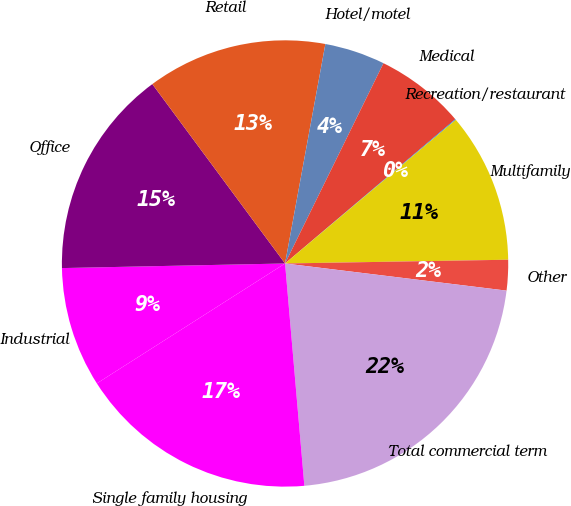<chart> <loc_0><loc_0><loc_500><loc_500><pie_chart><fcel>Industrial<fcel>Office<fcel>Retail<fcel>Hotel/motel<fcel>Medical<fcel>Recreation/restaurant<fcel>Multifamily<fcel>Other<fcel>Total commercial term<fcel>Single family housing<nl><fcel>8.7%<fcel>15.19%<fcel>13.03%<fcel>4.38%<fcel>6.54%<fcel>0.05%<fcel>10.87%<fcel>2.21%<fcel>21.68%<fcel>17.35%<nl></chart> 